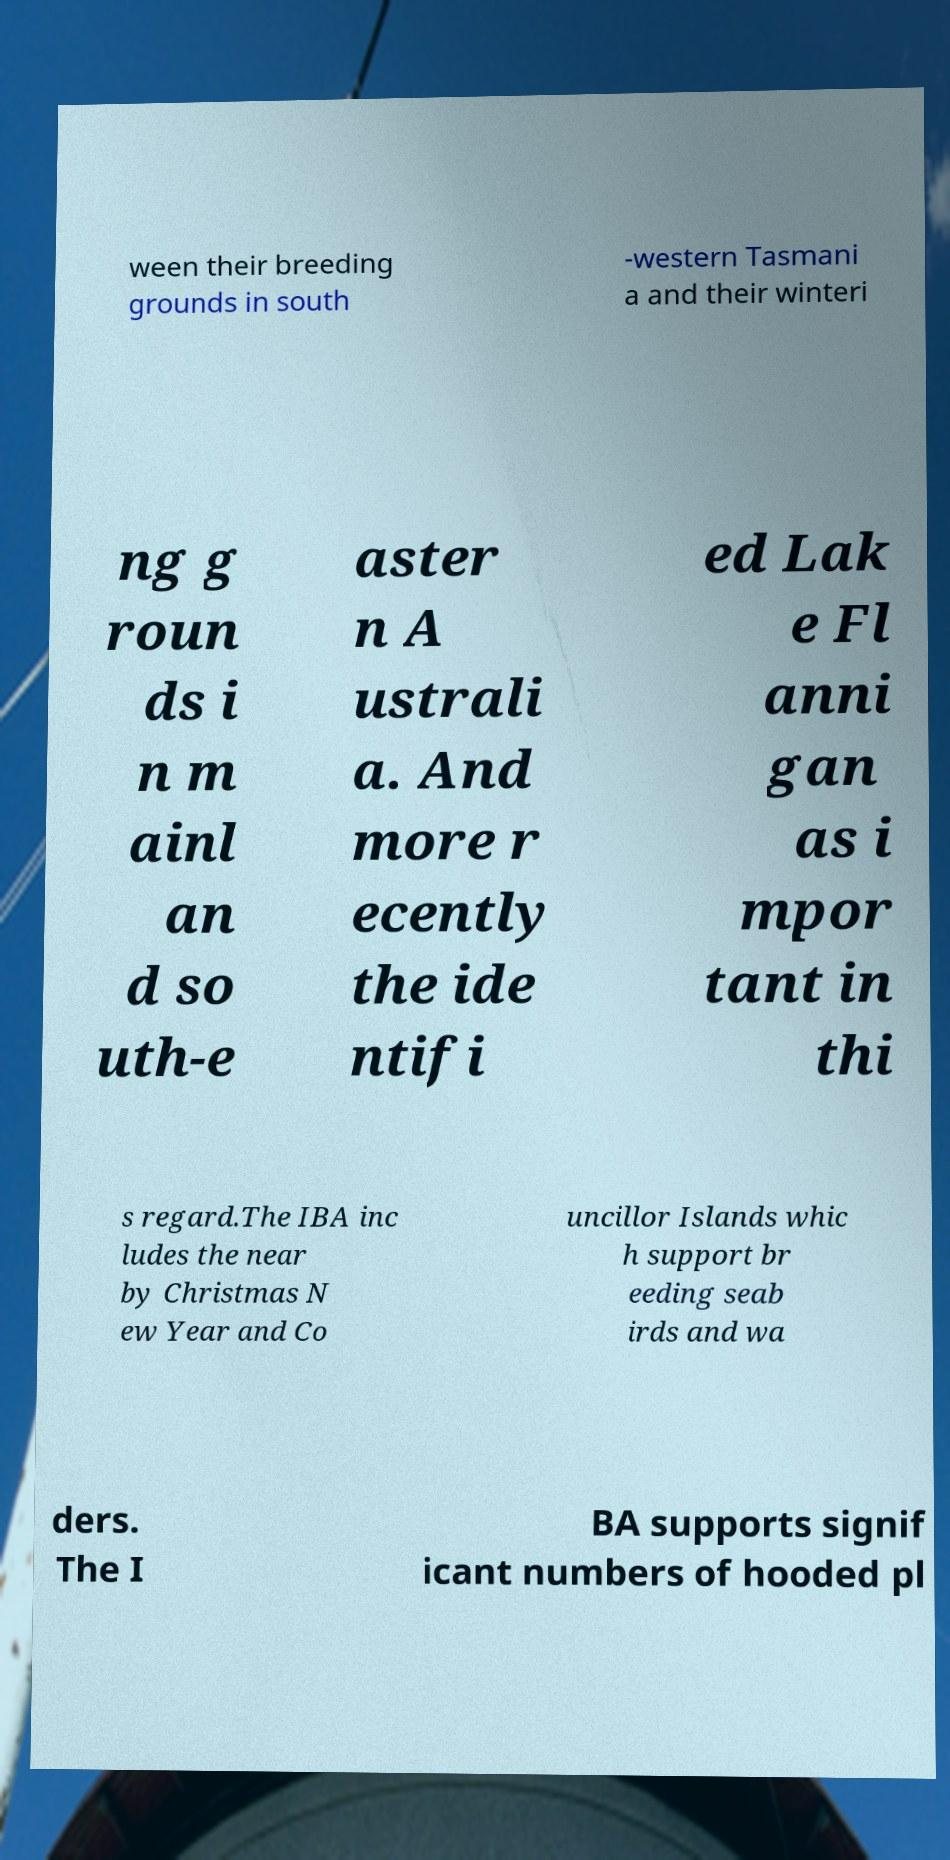What messages or text are displayed in this image? I need them in a readable, typed format. ween their breeding grounds in south -western Tasmani a and their winteri ng g roun ds i n m ainl an d so uth-e aster n A ustrali a. And more r ecently the ide ntifi ed Lak e Fl anni gan as i mpor tant in thi s regard.The IBA inc ludes the near by Christmas N ew Year and Co uncillor Islands whic h support br eeding seab irds and wa ders. The I BA supports signif icant numbers of hooded pl 